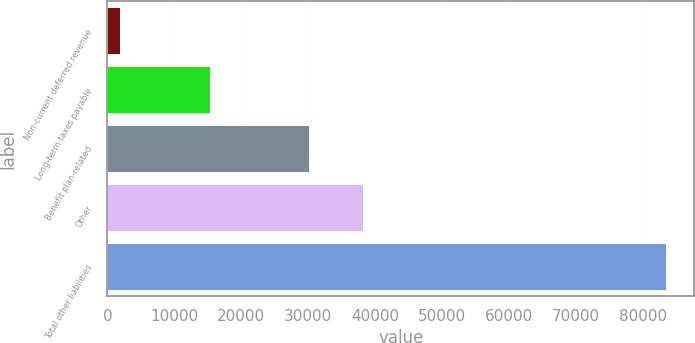<chart> <loc_0><loc_0><loc_500><loc_500><bar_chart><fcel>Non-current deferred revenue<fcel>Long-term taxes payable<fcel>Benefit plan-related<fcel>Other<fcel>Total other liabilities<nl><fcel>1913<fcel>15386<fcel>30098<fcel>38253.9<fcel>83472<nl></chart> 